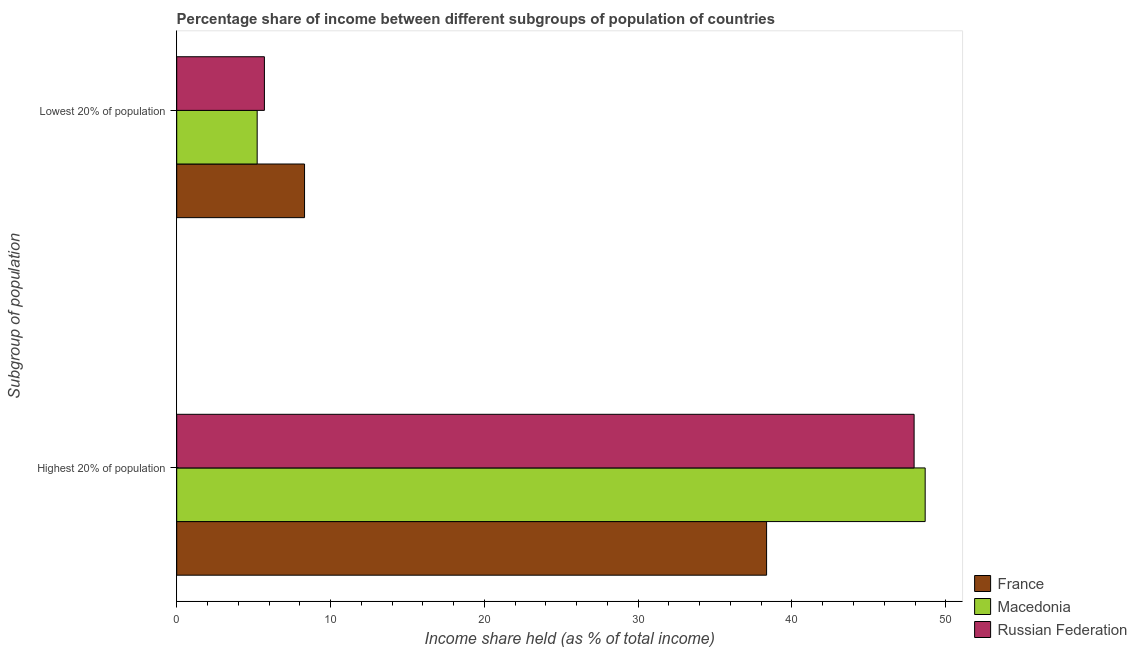How many different coloured bars are there?
Your answer should be compact. 3. How many bars are there on the 2nd tick from the top?
Your answer should be very brief. 3. How many bars are there on the 2nd tick from the bottom?
Your answer should be compact. 3. What is the label of the 1st group of bars from the top?
Provide a short and direct response. Lowest 20% of population. What is the income share held by lowest 20% of the population in Macedonia?
Offer a very short reply. 5.23. Across all countries, what is the maximum income share held by lowest 20% of the population?
Your answer should be compact. 8.31. Across all countries, what is the minimum income share held by highest 20% of the population?
Give a very brief answer. 38.35. In which country was the income share held by highest 20% of the population maximum?
Your response must be concise. Macedonia. In which country was the income share held by lowest 20% of the population minimum?
Make the answer very short. Macedonia. What is the total income share held by lowest 20% of the population in the graph?
Your response must be concise. 19.24. What is the difference between the income share held by highest 20% of the population in Macedonia and that in France?
Provide a short and direct response. 10.31. What is the difference between the income share held by lowest 20% of the population in Russian Federation and the income share held by highest 20% of the population in France?
Provide a short and direct response. -32.65. What is the average income share held by highest 20% of the population per country?
Your answer should be very brief. 44.98. What is the difference between the income share held by highest 20% of the population and income share held by lowest 20% of the population in Russian Federation?
Make the answer very short. 42.24. What is the ratio of the income share held by highest 20% of the population in Russian Federation to that in France?
Provide a succinct answer. 1.25. Is the income share held by lowest 20% of the population in Russian Federation less than that in Macedonia?
Your answer should be very brief. No. In how many countries, is the income share held by highest 20% of the population greater than the average income share held by highest 20% of the population taken over all countries?
Give a very brief answer. 2. What does the 1st bar from the top in Highest 20% of population represents?
Give a very brief answer. Russian Federation. What does the 1st bar from the bottom in Highest 20% of population represents?
Make the answer very short. France. How many bars are there?
Give a very brief answer. 6. What is the difference between two consecutive major ticks on the X-axis?
Your answer should be very brief. 10. Are the values on the major ticks of X-axis written in scientific E-notation?
Provide a succinct answer. No. Does the graph contain any zero values?
Ensure brevity in your answer.  No. Does the graph contain grids?
Give a very brief answer. No. Where does the legend appear in the graph?
Keep it short and to the point. Bottom right. How many legend labels are there?
Provide a short and direct response. 3. How are the legend labels stacked?
Ensure brevity in your answer.  Vertical. What is the title of the graph?
Make the answer very short. Percentage share of income between different subgroups of population of countries. Does "Middle income" appear as one of the legend labels in the graph?
Your answer should be compact. No. What is the label or title of the X-axis?
Offer a very short reply. Income share held (as % of total income). What is the label or title of the Y-axis?
Provide a short and direct response. Subgroup of population. What is the Income share held (as % of total income) in France in Highest 20% of population?
Make the answer very short. 38.35. What is the Income share held (as % of total income) in Macedonia in Highest 20% of population?
Your answer should be compact. 48.66. What is the Income share held (as % of total income) in Russian Federation in Highest 20% of population?
Ensure brevity in your answer.  47.94. What is the Income share held (as % of total income) in France in Lowest 20% of population?
Make the answer very short. 8.31. What is the Income share held (as % of total income) in Macedonia in Lowest 20% of population?
Ensure brevity in your answer.  5.23. Across all Subgroup of population, what is the maximum Income share held (as % of total income) of France?
Offer a terse response. 38.35. Across all Subgroup of population, what is the maximum Income share held (as % of total income) of Macedonia?
Your answer should be very brief. 48.66. Across all Subgroup of population, what is the maximum Income share held (as % of total income) in Russian Federation?
Make the answer very short. 47.94. Across all Subgroup of population, what is the minimum Income share held (as % of total income) of France?
Your answer should be compact. 8.31. Across all Subgroup of population, what is the minimum Income share held (as % of total income) of Macedonia?
Keep it short and to the point. 5.23. Across all Subgroup of population, what is the minimum Income share held (as % of total income) of Russian Federation?
Provide a short and direct response. 5.7. What is the total Income share held (as % of total income) in France in the graph?
Your response must be concise. 46.66. What is the total Income share held (as % of total income) in Macedonia in the graph?
Your answer should be very brief. 53.89. What is the total Income share held (as % of total income) of Russian Federation in the graph?
Provide a short and direct response. 53.64. What is the difference between the Income share held (as % of total income) of France in Highest 20% of population and that in Lowest 20% of population?
Your answer should be very brief. 30.04. What is the difference between the Income share held (as % of total income) of Macedonia in Highest 20% of population and that in Lowest 20% of population?
Give a very brief answer. 43.43. What is the difference between the Income share held (as % of total income) of Russian Federation in Highest 20% of population and that in Lowest 20% of population?
Give a very brief answer. 42.24. What is the difference between the Income share held (as % of total income) of France in Highest 20% of population and the Income share held (as % of total income) of Macedonia in Lowest 20% of population?
Ensure brevity in your answer.  33.12. What is the difference between the Income share held (as % of total income) of France in Highest 20% of population and the Income share held (as % of total income) of Russian Federation in Lowest 20% of population?
Give a very brief answer. 32.65. What is the difference between the Income share held (as % of total income) of Macedonia in Highest 20% of population and the Income share held (as % of total income) of Russian Federation in Lowest 20% of population?
Offer a terse response. 42.96. What is the average Income share held (as % of total income) of France per Subgroup of population?
Your answer should be very brief. 23.33. What is the average Income share held (as % of total income) in Macedonia per Subgroup of population?
Give a very brief answer. 26.95. What is the average Income share held (as % of total income) in Russian Federation per Subgroup of population?
Make the answer very short. 26.82. What is the difference between the Income share held (as % of total income) in France and Income share held (as % of total income) in Macedonia in Highest 20% of population?
Keep it short and to the point. -10.31. What is the difference between the Income share held (as % of total income) in France and Income share held (as % of total income) in Russian Federation in Highest 20% of population?
Offer a terse response. -9.59. What is the difference between the Income share held (as % of total income) of Macedonia and Income share held (as % of total income) of Russian Federation in Highest 20% of population?
Provide a short and direct response. 0.72. What is the difference between the Income share held (as % of total income) of France and Income share held (as % of total income) of Macedonia in Lowest 20% of population?
Provide a succinct answer. 3.08. What is the difference between the Income share held (as % of total income) in France and Income share held (as % of total income) in Russian Federation in Lowest 20% of population?
Offer a terse response. 2.61. What is the difference between the Income share held (as % of total income) of Macedonia and Income share held (as % of total income) of Russian Federation in Lowest 20% of population?
Offer a terse response. -0.47. What is the ratio of the Income share held (as % of total income) of France in Highest 20% of population to that in Lowest 20% of population?
Provide a short and direct response. 4.61. What is the ratio of the Income share held (as % of total income) in Macedonia in Highest 20% of population to that in Lowest 20% of population?
Make the answer very short. 9.3. What is the ratio of the Income share held (as % of total income) in Russian Federation in Highest 20% of population to that in Lowest 20% of population?
Ensure brevity in your answer.  8.41. What is the difference between the highest and the second highest Income share held (as % of total income) of France?
Provide a short and direct response. 30.04. What is the difference between the highest and the second highest Income share held (as % of total income) of Macedonia?
Keep it short and to the point. 43.43. What is the difference between the highest and the second highest Income share held (as % of total income) in Russian Federation?
Your answer should be very brief. 42.24. What is the difference between the highest and the lowest Income share held (as % of total income) in France?
Ensure brevity in your answer.  30.04. What is the difference between the highest and the lowest Income share held (as % of total income) of Macedonia?
Keep it short and to the point. 43.43. What is the difference between the highest and the lowest Income share held (as % of total income) in Russian Federation?
Make the answer very short. 42.24. 